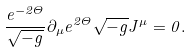<formula> <loc_0><loc_0><loc_500><loc_500>\frac { e ^ { - 2 \Theta } } { \sqrt { - g } } \partial _ { \mu } e ^ { 2 \Theta } \sqrt { - g } J ^ { \mu } = 0 .</formula> 